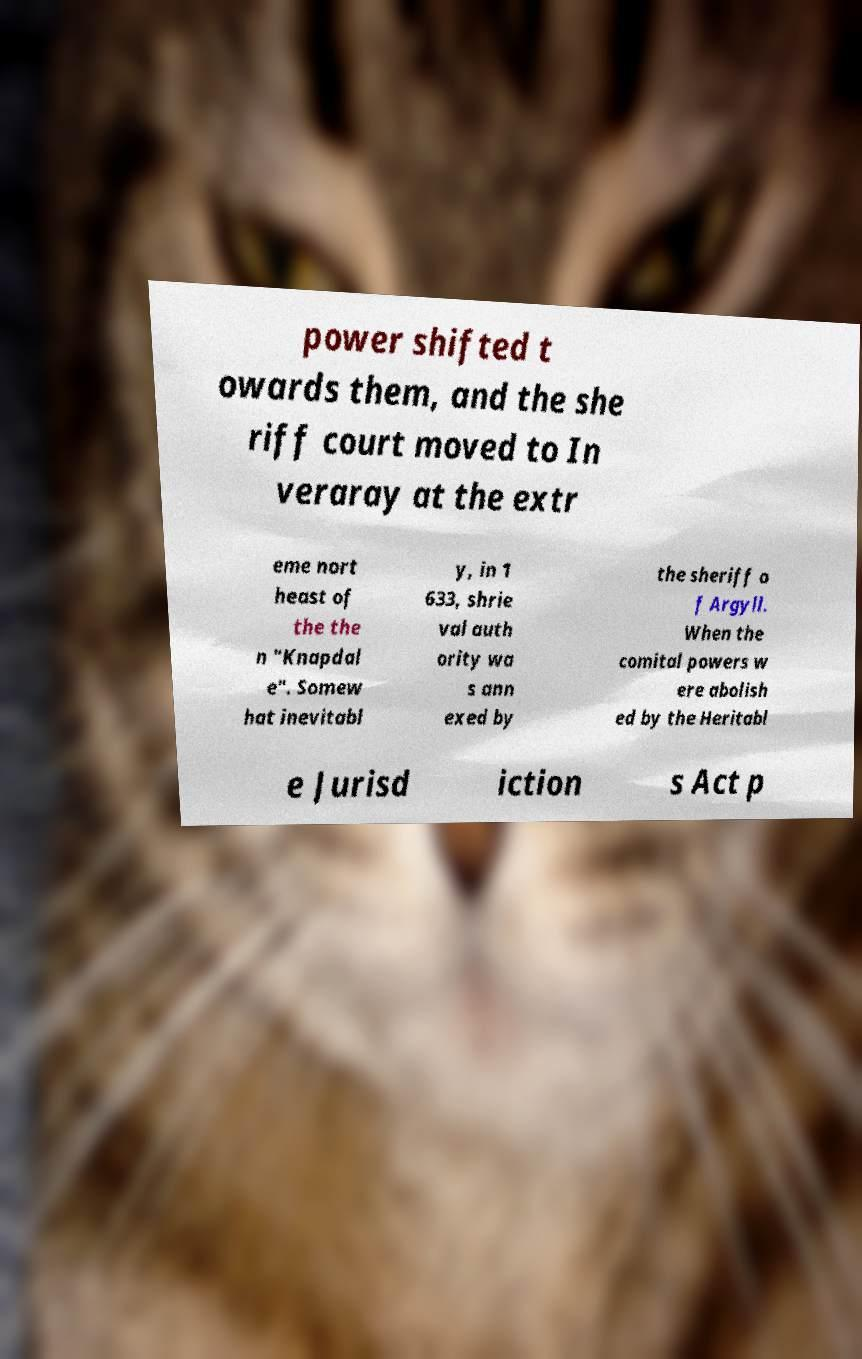Could you assist in decoding the text presented in this image and type it out clearly? power shifted t owards them, and the she riff court moved to In veraray at the extr eme nort heast of the the n "Knapdal e". Somew hat inevitabl y, in 1 633, shrie val auth ority wa s ann exed by the sheriff o f Argyll. When the comital powers w ere abolish ed by the Heritabl e Jurisd iction s Act p 